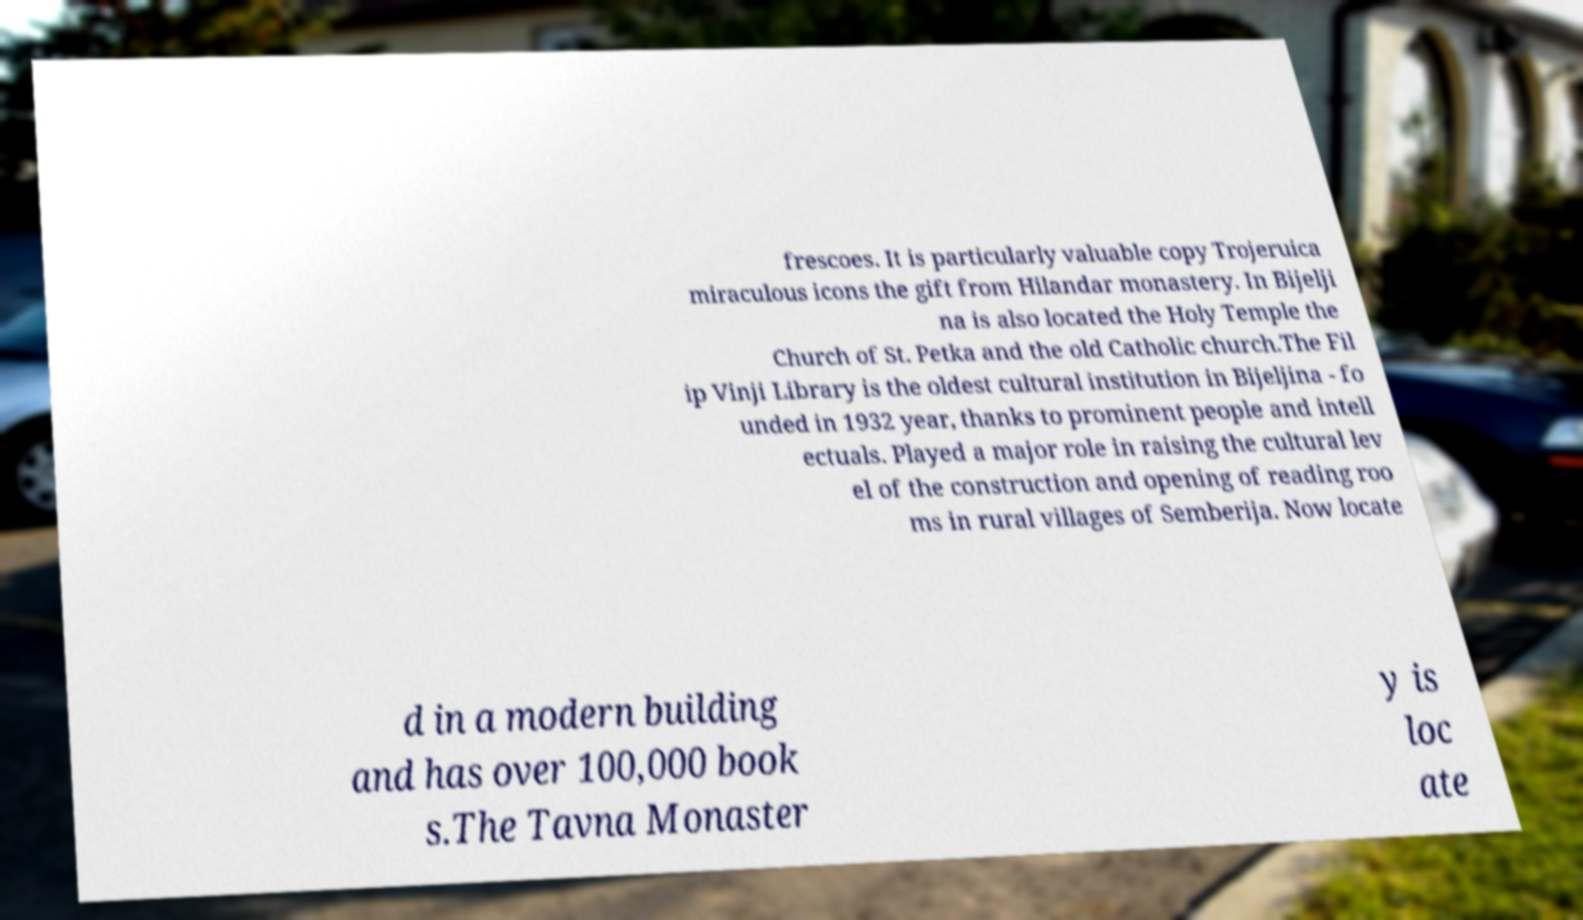Can you read and provide the text displayed in the image?This photo seems to have some interesting text. Can you extract and type it out for me? frescoes. It is particularly valuable copy Trojeruica miraculous icons the gift from Hilandar monastery. In Bijelji na is also located the Holy Temple the Church of St. Petka and the old Catholic church.The Fil ip Vinji Library is the oldest cultural institution in Bijeljina - fo unded in 1932 year, thanks to prominent people and intell ectuals. Played a major role in raising the cultural lev el of the construction and opening of reading roo ms in rural villages of Semberija. Now locate d in a modern building and has over 100,000 book s.The Tavna Monaster y is loc ate 